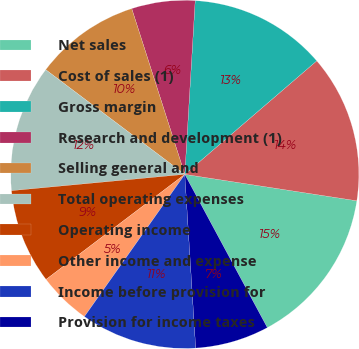Convert chart. <chart><loc_0><loc_0><loc_500><loc_500><pie_chart><fcel>Net sales<fcel>Cost of sales (1)<fcel>Gross margin<fcel>Research and development (1)<fcel>Selling general and<fcel>Total operating expenses<fcel>Operating income<fcel>Other income and expense<fcel>Income before provision for<fcel>Provision for income taxes<nl><fcel>14.71%<fcel>13.73%<fcel>12.74%<fcel>5.88%<fcel>9.8%<fcel>11.76%<fcel>8.82%<fcel>4.9%<fcel>10.78%<fcel>6.86%<nl></chart> 